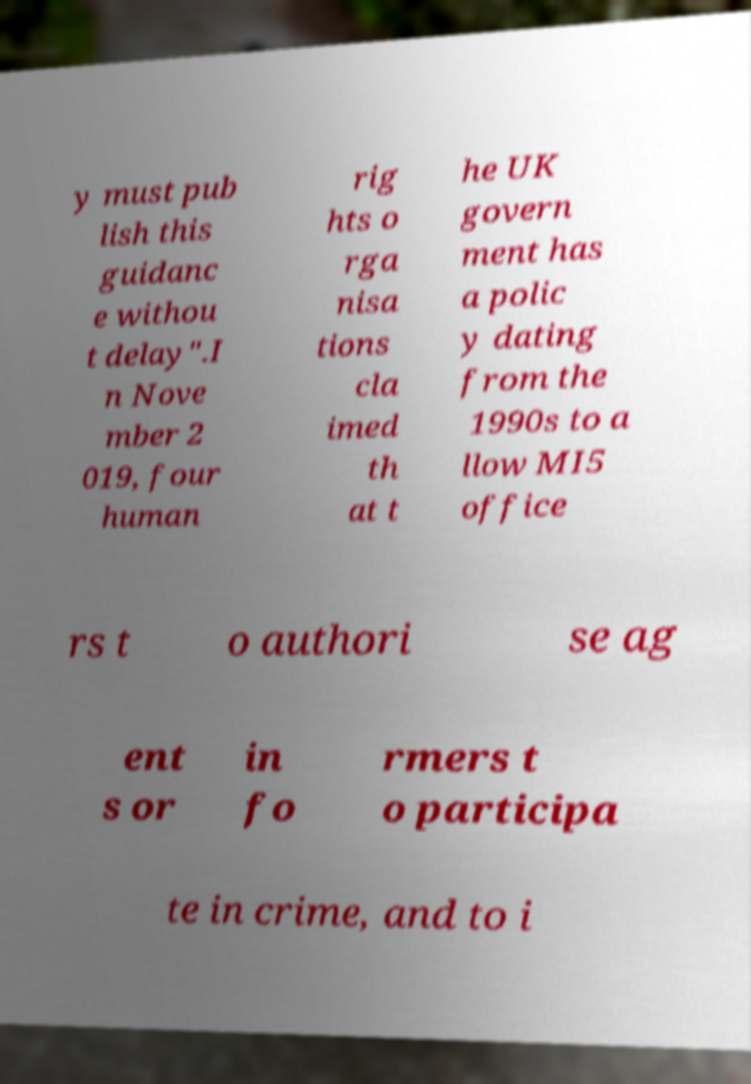Please identify and transcribe the text found in this image. y must pub lish this guidanc e withou t delay".I n Nove mber 2 019, four human rig hts o rga nisa tions cla imed th at t he UK govern ment has a polic y dating from the 1990s to a llow MI5 office rs t o authori se ag ent s or in fo rmers t o participa te in crime, and to i 